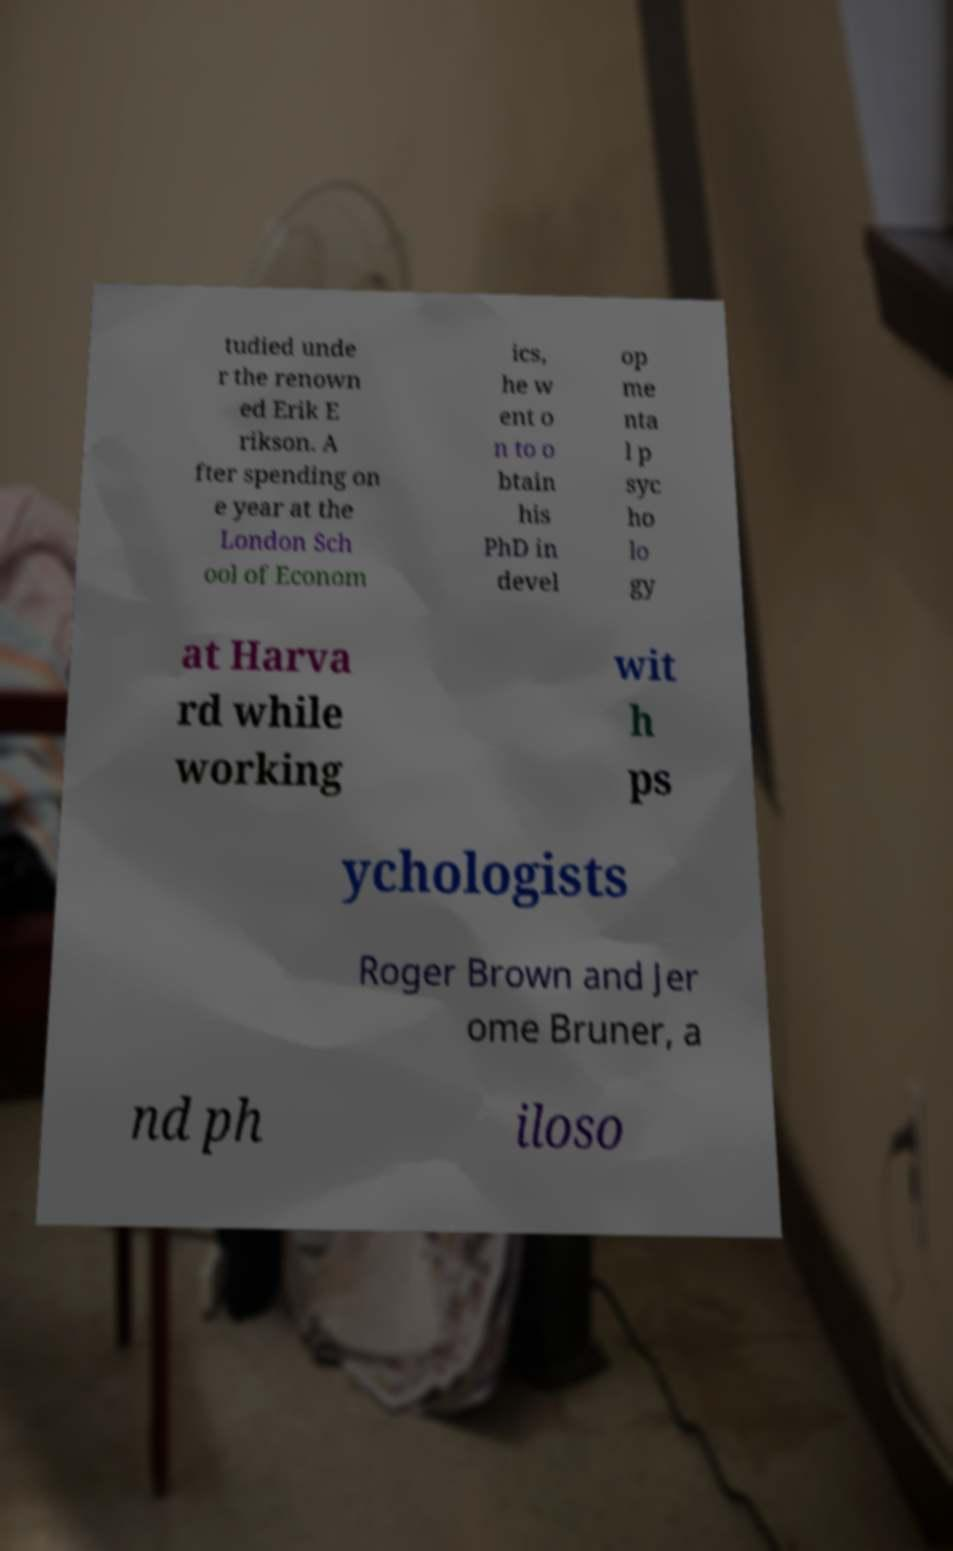Can you accurately transcribe the text from the provided image for me? tudied unde r the renown ed Erik E rikson. A fter spending on e year at the London Sch ool of Econom ics, he w ent o n to o btain his PhD in devel op me nta l p syc ho lo gy at Harva rd while working wit h ps ychologists Roger Brown and Jer ome Bruner, a nd ph iloso 